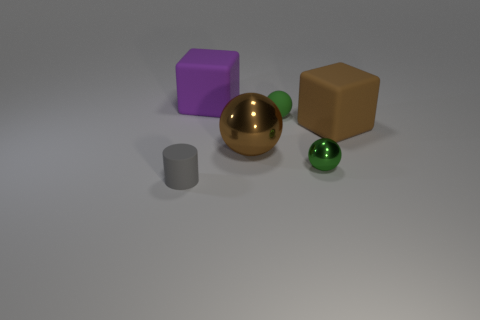Is the number of objects left of the matte cylinder greater than the number of matte cylinders?
Your response must be concise. No. What material is the purple thing?
Provide a succinct answer. Rubber. What number of gray things have the same size as the brown matte thing?
Ensure brevity in your answer.  0. Is the number of rubber balls in front of the small shiny object the same as the number of brown balls that are behind the purple matte object?
Your response must be concise. Yes. Is the tiny cylinder made of the same material as the large brown cube?
Provide a short and direct response. Yes. Is there a large object on the right side of the purple rubber block that is on the left side of the brown metal ball?
Offer a terse response. Yes. Is there another big rubber thing that has the same shape as the gray matte thing?
Offer a very short reply. No. Is the color of the large ball the same as the cylinder?
Keep it short and to the point. No. There is a big cube that is behind the tiny rubber object behind the small gray object; what is it made of?
Keep it short and to the point. Rubber. The gray rubber cylinder is what size?
Your answer should be compact. Small. 